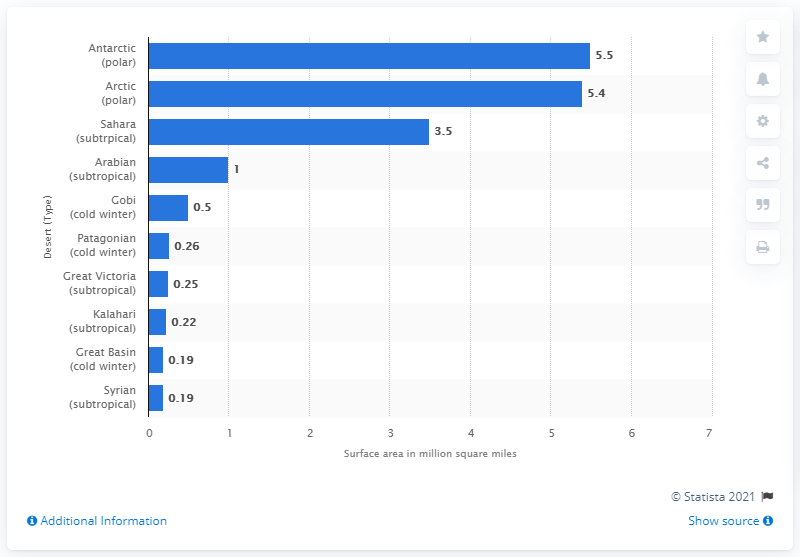List a handful of essential elements in this visual. The Antarctic desert is approximately 5.5 million square kilometers in size. 